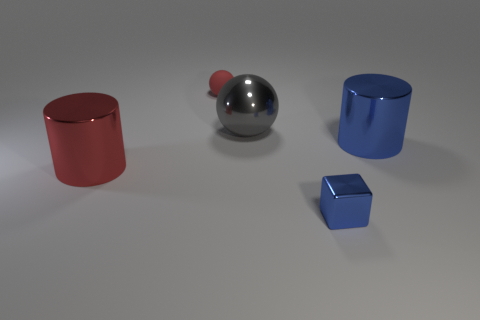Add 2 brown rubber objects. How many objects exist? 7 Subtract all cylinders. How many objects are left? 3 Add 3 large red metal objects. How many large red metal objects are left? 4 Add 5 cubes. How many cubes exist? 6 Subtract 0 cyan cubes. How many objects are left? 5 Subtract all tiny red matte cylinders. Subtract all blocks. How many objects are left? 4 